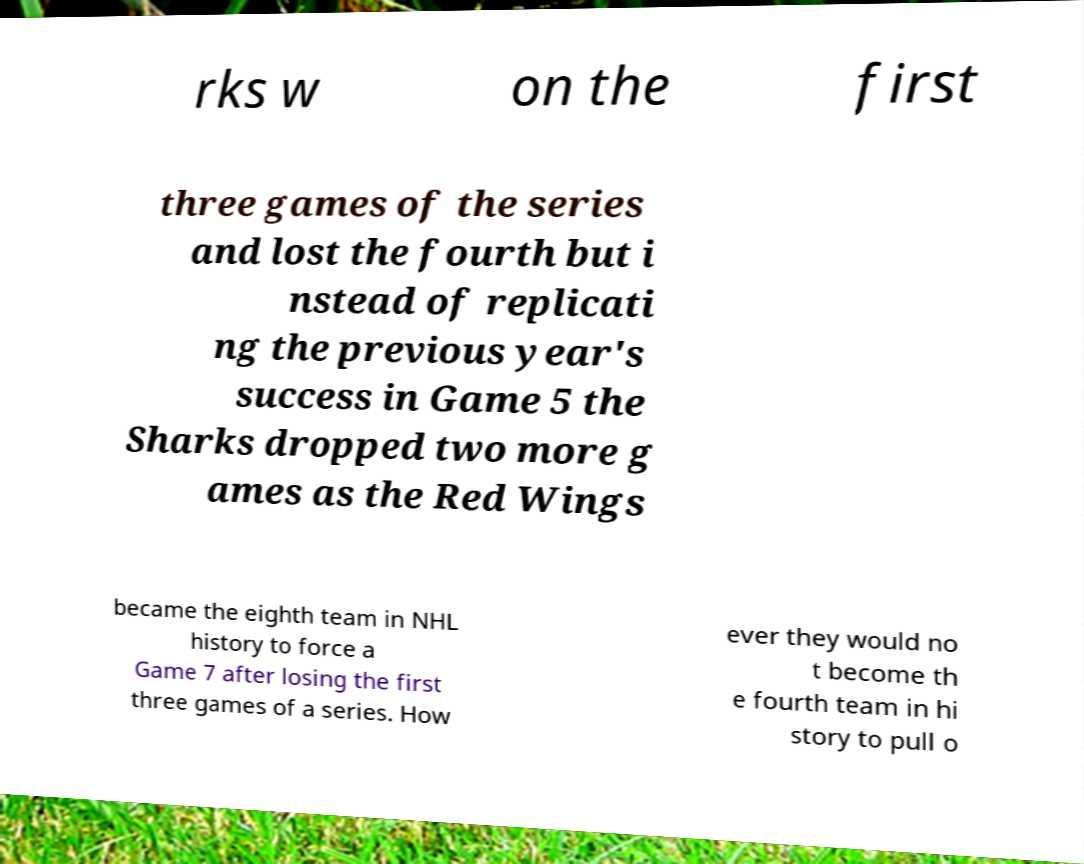Please read and relay the text visible in this image. What does it say? rks w on the first three games of the series and lost the fourth but i nstead of replicati ng the previous year's success in Game 5 the Sharks dropped two more g ames as the Red Wings became the eighth team in NHL history to force a Game 7 after losing the first three games of a series. How ever they would no t become th e fourth team in hi story to pull o 